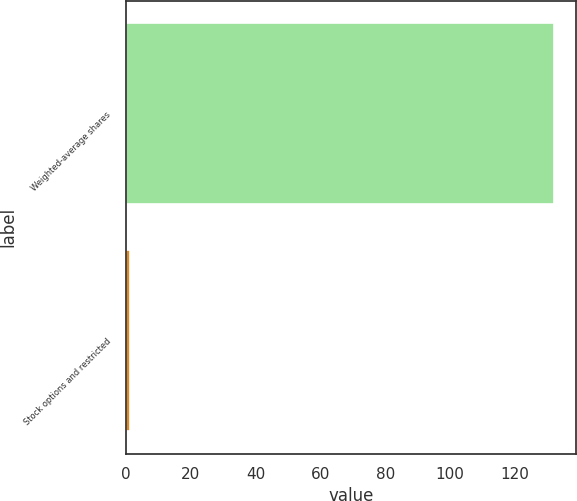Convert chart to OTSL. <chart><loc_0><loc_0><loc_500><loc_500><bar_chart><fcel>Weighted-average shares<fcel>Stock options and restricted<nl><fcel>132.11<fcel>1.4<nl></chart> 